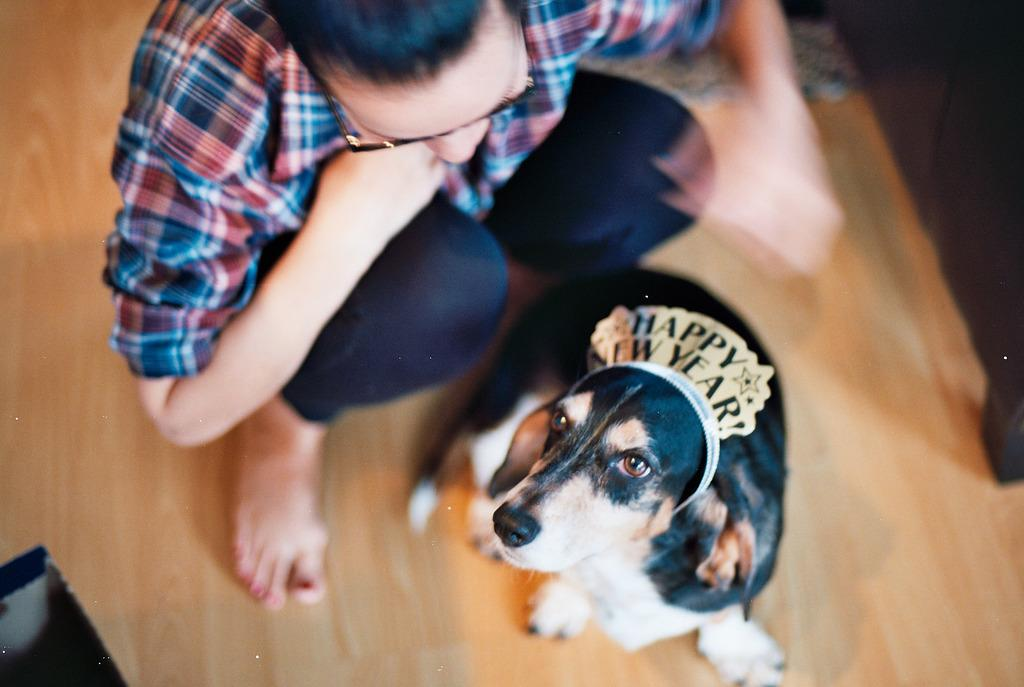What is the main subject of the image? There is a guy in the image. How is the guy positioned in the image? The guy is in a squatting position. What is in front of the guy? There is a puppy dog in front of the guy. What is unique about the puppy dog? The puppy dog has a hair clip. What does the hair clip say? The hair clip says "happy new year" on it. What is the floor made of? The floor is made of maple wood. Where is the lock that the guy is using to secure the geese in the image? There are no geese or locks present in the image. What type of hat is the puppy dog wearing in the image? The puppy dog is not wearing a hat in the image. 